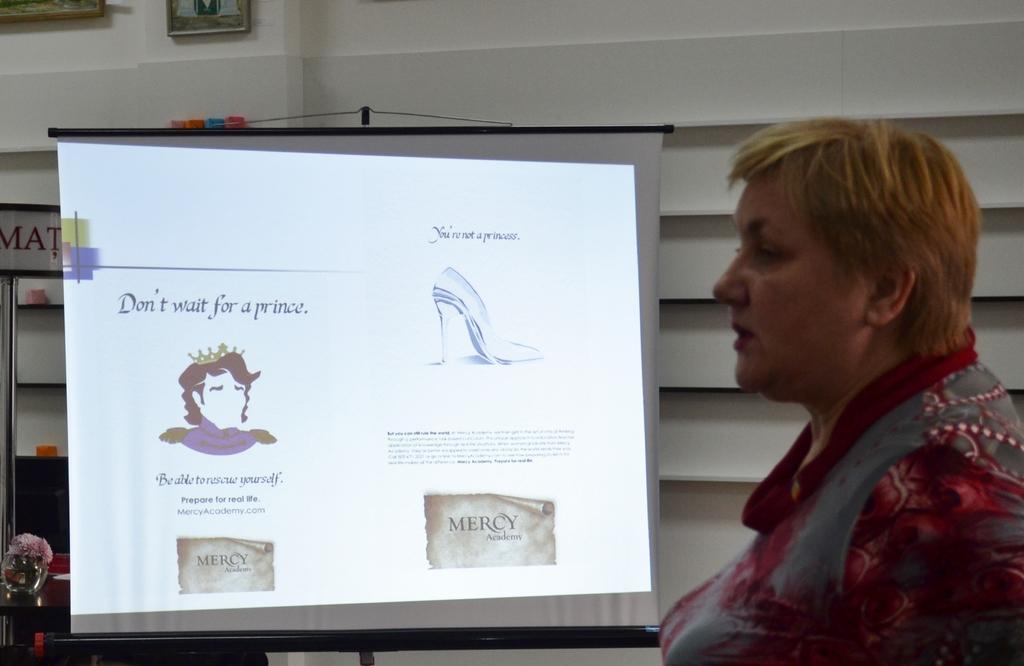How would you summarize this image in a sentence or two? In the picture we can see a woman with a short hair and she is looking at the screen which is hanged to the stand on the screen we can see some images and some information and in the background we can see a wall with some photo frames. 